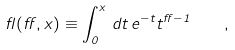<formula> <loc_0><loc_0><loc_500><loc_500>\gamma ( \alpha , x ) \equiv \int _ { 0 } ^ { x } \, d t \, e ^ { - t } t ^ { \alpha - 1 } \quad ,</formula> 